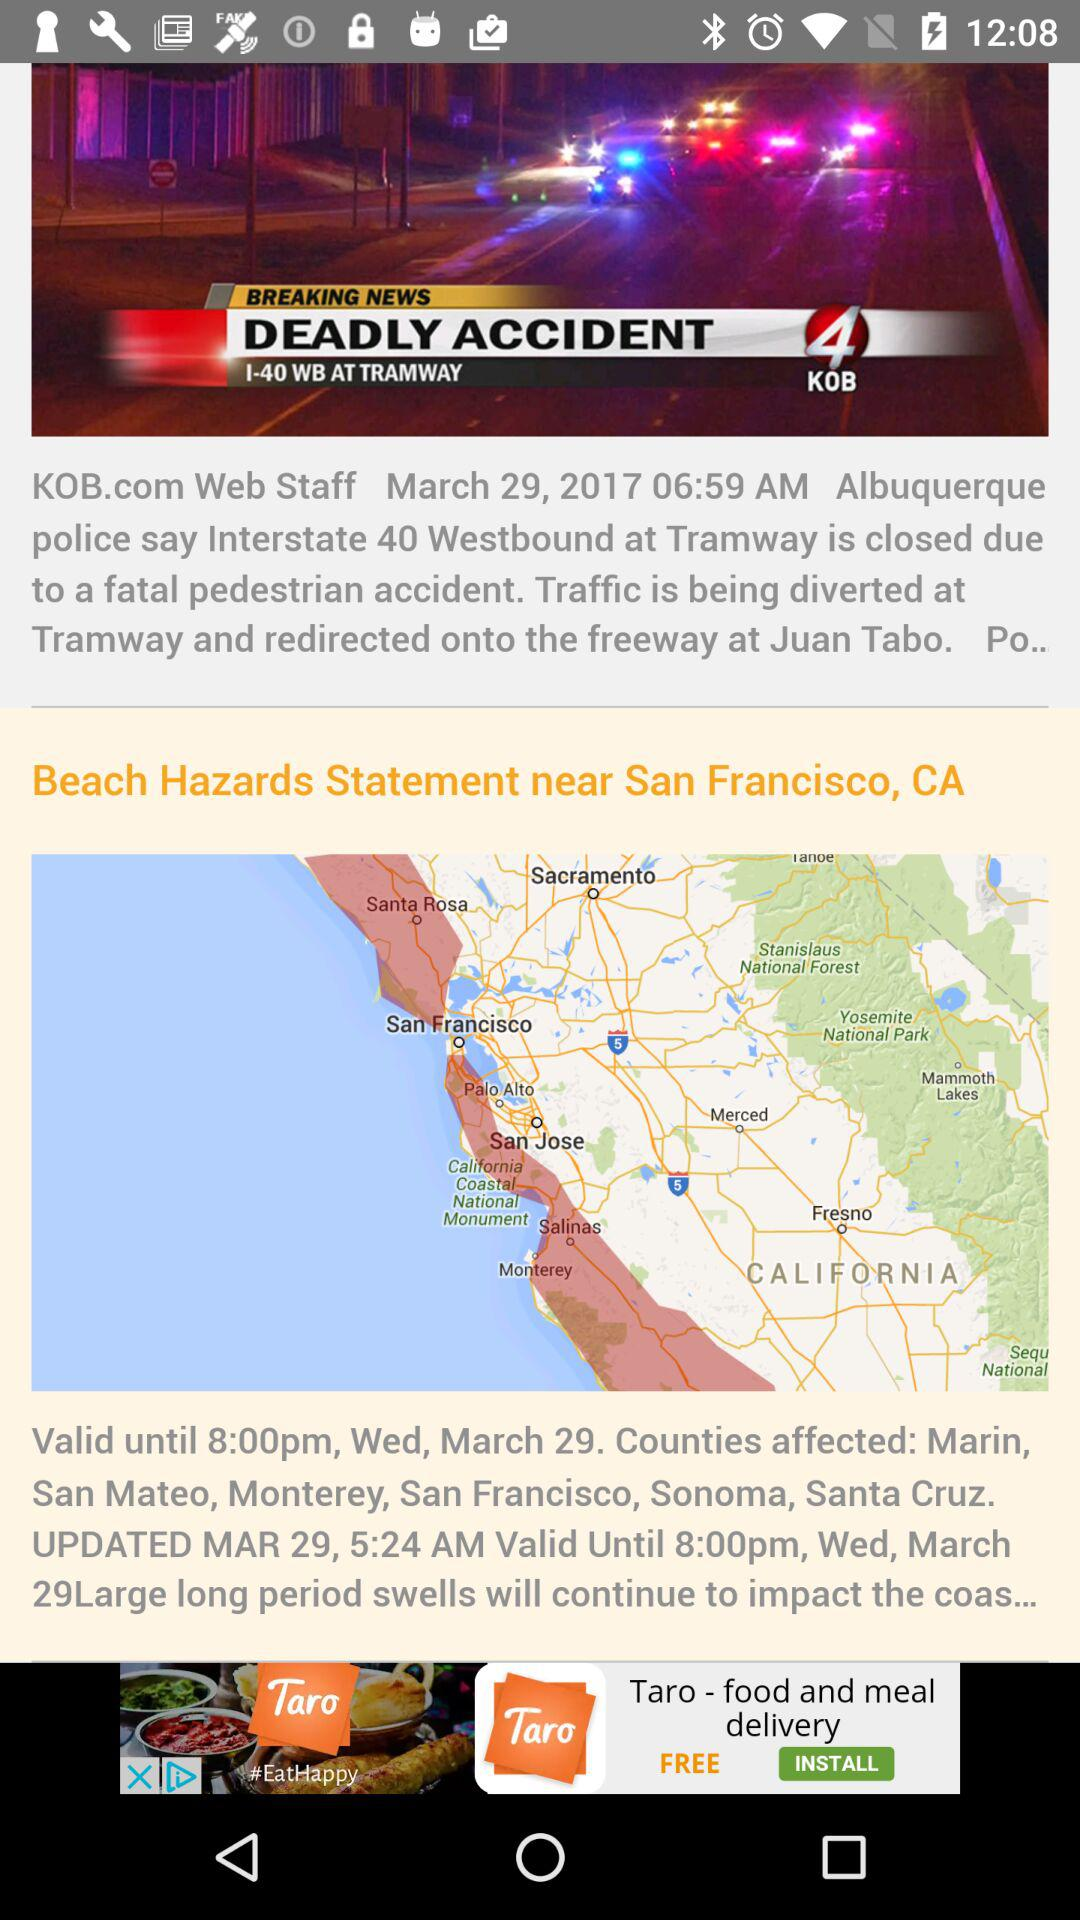How many counties are affected by the beach hazards statement?
Answer the question using a single word or phrase. 6 